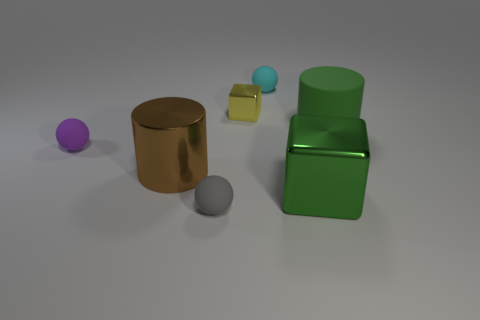What time of day does the lighting in the scene suggest? The lighting in the scene doesn't strongly suggest any particular time of day. It's a controlled, diffused light typically used in studio lighting, providing uniform illumination to the objects without creating harsh shadows or a directional light source that would indicate a time of day such as morning or afternoon. 